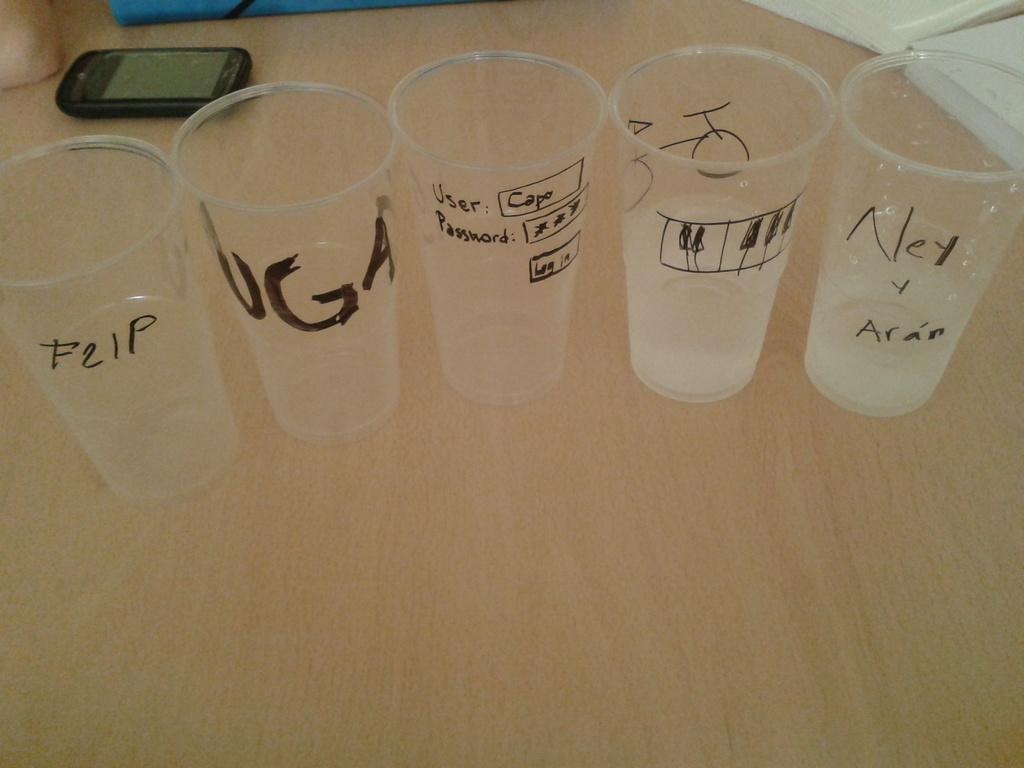<image>
Summarize the visual content of the image. A clear cup that has "F21p" written on it in black marker sits on a table near several other clear cups with writing on them. 